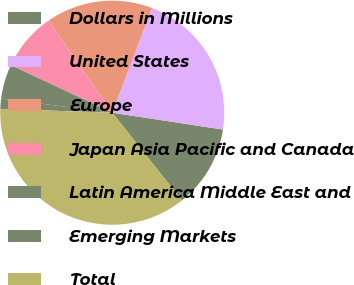<chart> <loc_0><loc_0><loc_500><loc_500><pie_chart><fcel>Dollars in Millions<fcel>United States<fcel>Europe<fcel>Japan Asia Pacific and Canada<fcel>Latin America Middle East and<fcel>Emerging Markets<fcel>Total<nl><fcel>11.91%<fcel>21.61%<fcel>15.38%<fcel>8.43%<fcel>4.96%<fcel>1.48%<fcel>36.23%<nl></chart> 